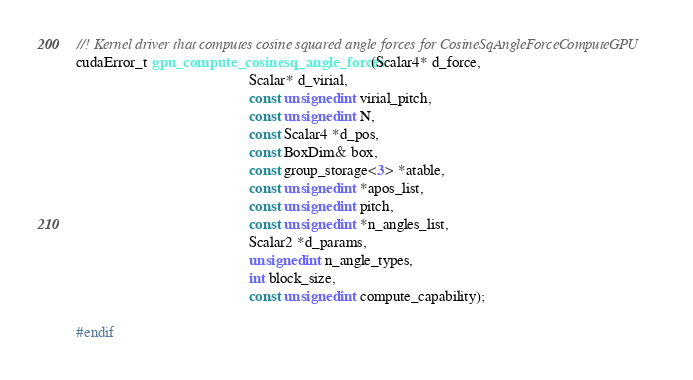<code> <loc_0><loc_0><loc_500><loc_500><_Cuda_>//! Kernel driver that computes cosine squared angle forces for CosineSqAngleForceComputeGPU
cudaError_t gpu_compute_cosinesq_angle_forces(Scalar4* d_force,
                                              Scalar* d_virial,
                                              const unsigned int virial_pitch,
                                              const unsigned int N,
                                              const Scalar4 *d_pos,
                                              const BoxDim& box,
                                              const group_storage<3> *atable,
                                              const unsigned int *apos_list,
                                              const unsigned int pitch,
                                              const unsigned int *n_angles_list,
                                              Scalar2 *d_params,
                                              unsigned int n_angle_types,
                                              int block_size,
                                              const unsigned int compute_capability);

#endif
</code> 